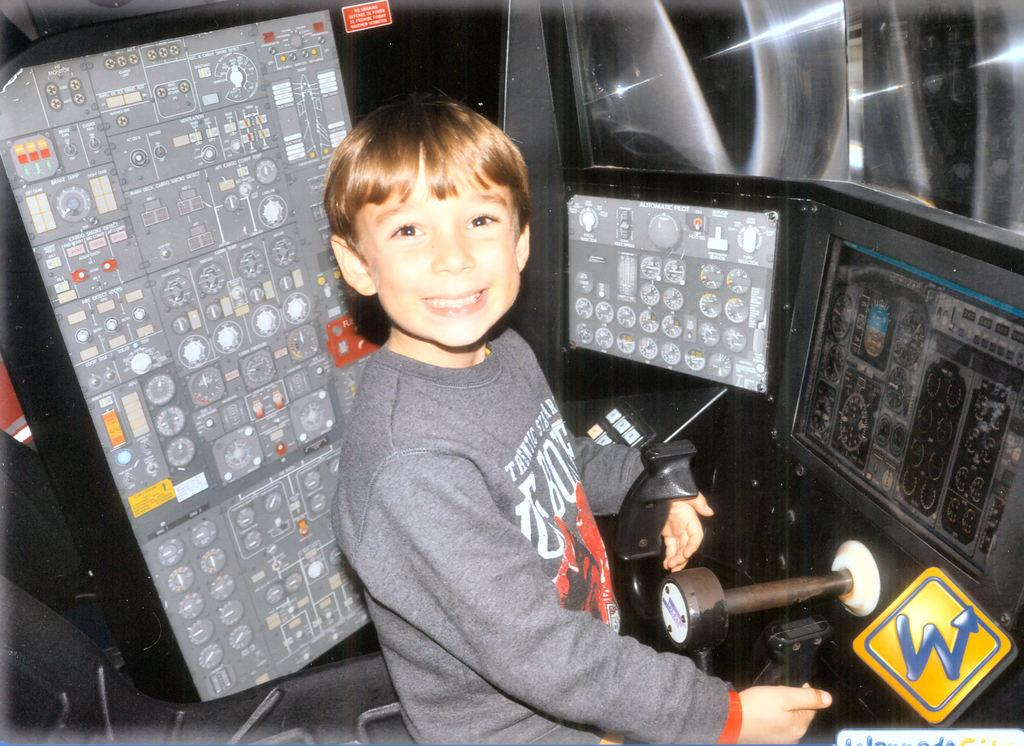<image>
Render a clear and concise summary of the photo. A boy with the letters B and O on his shirt stand near some control panels. 